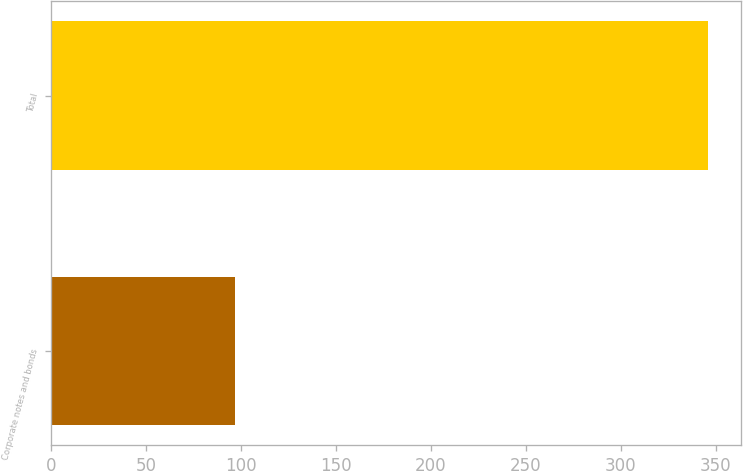Convert chart. <chart><loc_0><loc_0><loc_500><loc_500><bar_chart><fcel>Corporate notes and bonds<fcel>Total<nl><fcel>97<fcel>346<nl></chart> 